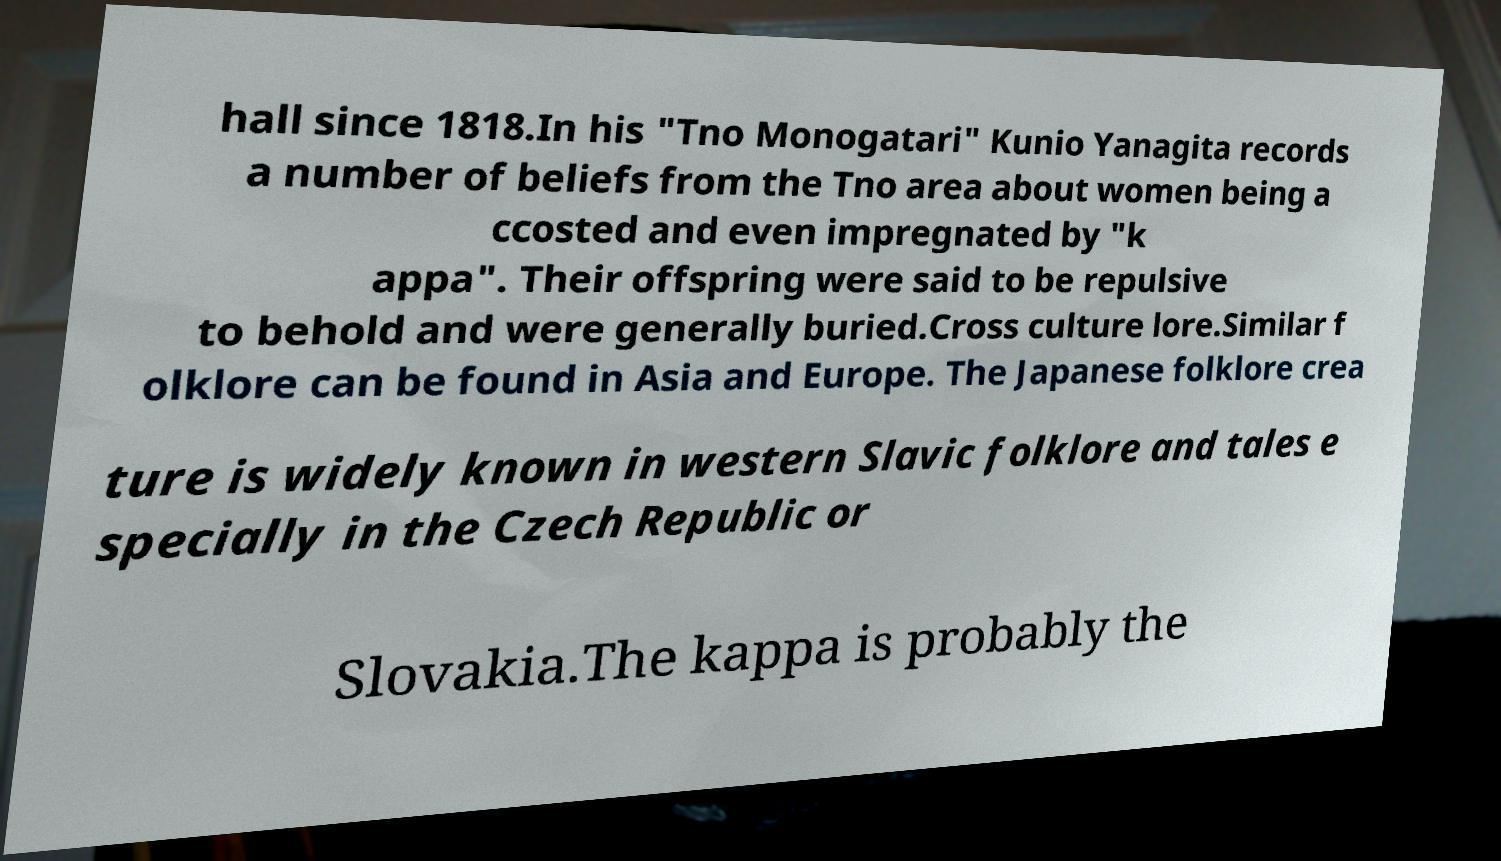Please read and relay the text visible in this image. What does it say? hall since 1818.In his "Tno Monogatari" Kunio Yanagita records a number of beliefs from the Tno area about women being a ccosted and even impregnated by "k appa". Their offspring were said to be repulsive to behold and were generally buried.Cross culture lore.Similar f olklore can be found in Asia and Europe. The Japanese folklore crea ture is widely known in western Slavic folklore and tales e specially in the Czech Republic or Slovakia.The kappa is probably the 